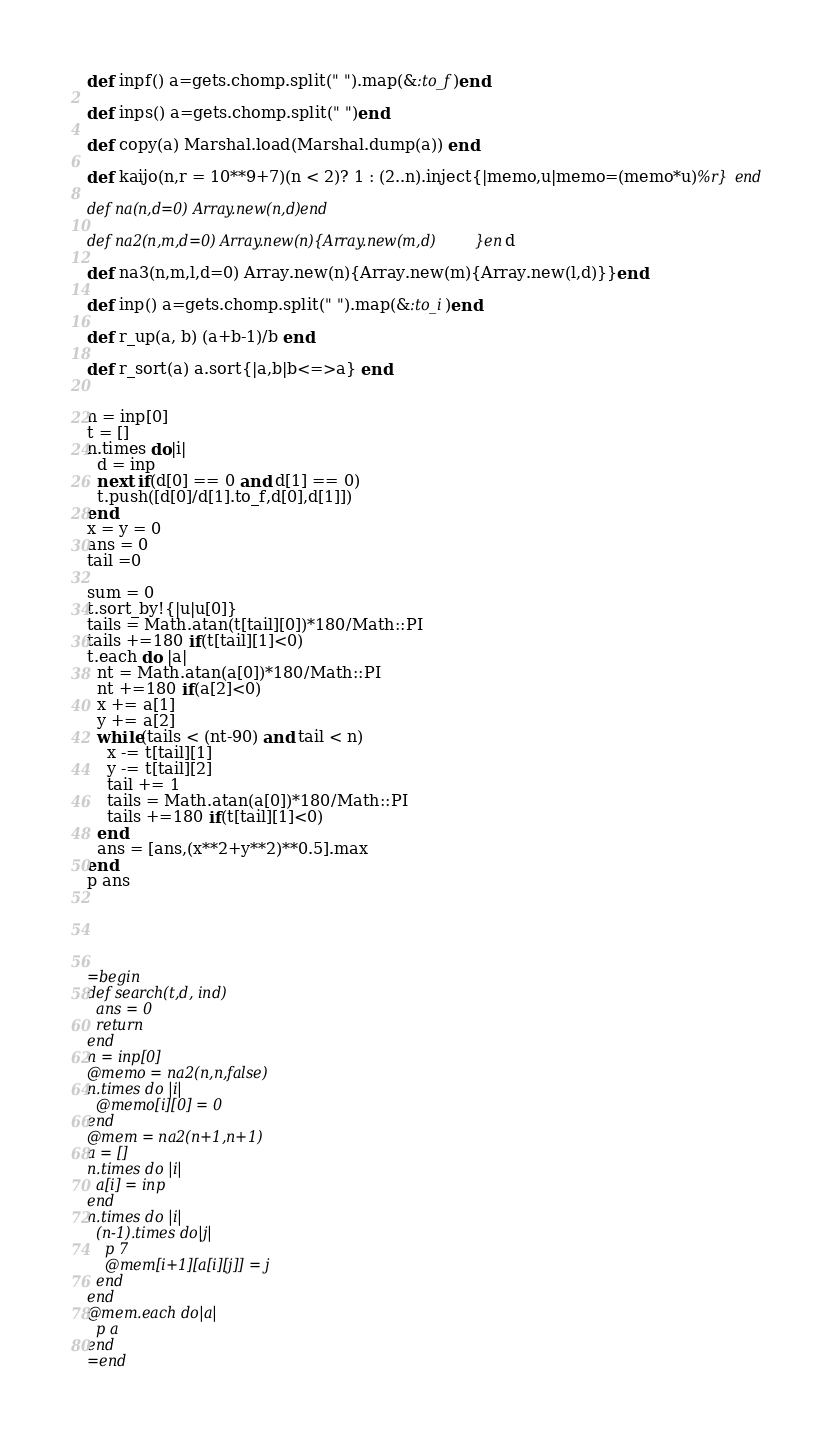Convert code to text. <code><loc_0><loc_0><loc_500><loc_500><_Ruby_>def inpf() a=gets.chomp.split(" ").map(&:to_f)end

def inps() a=gets.chomp.split(" ")end

def copy(a) Marshal.load(Marshal.dump(a)) end

def kaijo(n,r = 10**9+7)(n < 2)? 1 : (2..n).inject{|memo,u|memo=(memo*u)%r} end

def na(n,d=0) Array.new(n,d)end

def na2(n,m,d=0) Array.new(n){Array.new(m,d)}end

def na3(n,m,l,d=0) Array.new(n){Array.new(m){Array.new(l,d)}}end

def inp() a=gets.chomp.split(" ").map(&:to_i)end

def r_up(a, b) (a+b-1)/b end

def r_sort(a) a.sort{|a,b|b<=>a} end


n = inp[0]
t = []
n.times do|i|
  d = inp
  next if(d[0] == 0 and d[1] == 0)
  t.push([d[0]/d[1].to_f,d[0],d[1]])
end
x = y = 0
ans = 0
tail =0

sum = 0
t.sort_by!{|u|u[0]}
tails = Math.atan(t[tail][0])*180/Math::PI
tails +=180 if(t[tail][1]<0)
t.each do |a|
  nt = Math.atan(a[0])*180/Math::PI
  nt +=180 if(a[2]<0)
  x += a[1]
  y += a[2]
  while(tails < (nt-90) and tail < n)
    x -= t[tail][1]
    y -= t[tail][2]
    tail += 1
    tails = Math.atan(a[0])*180/Math::PI
    tails +=180 if(t[tail][1]<0)
  end
  ans = [ans,(x**2+y**2)**0.5].max
end
p ans





=begin
def search(t,d, ind)
  ans = 0
  return
end
n = inp[0]
@memo = na2(n,n,false)
n.times do |i|
  @memo[i][0] = 0
end
@mem = na2(n+1,n+1)
a = []
n.times do |i|
  a[i] = inp
end
n.times do |i|
  (n-1).times do|j|
    p 7
    @mem[i+1][a[i][j]] = j
  end
end
@mem.each do|a|
  p a
end
=end</code> 